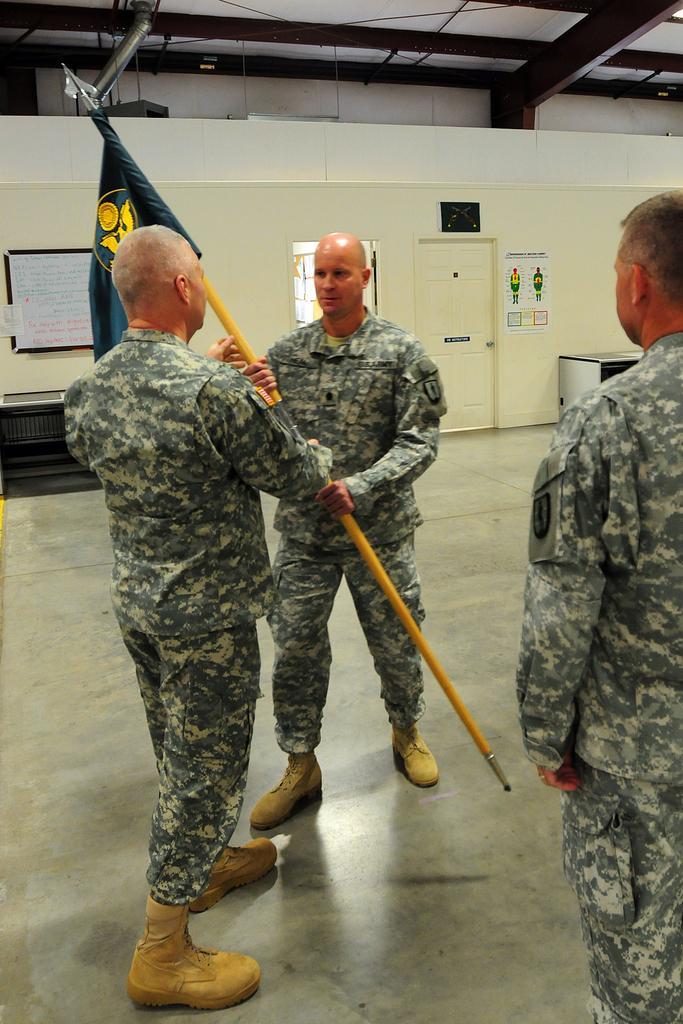Please provide a concise description of this image. In the picture I can see two soldiers standing and holding a rod in their hands which has a flag attached to it and there is another person standing in the right corner and there is a door and some other objects in the background. 